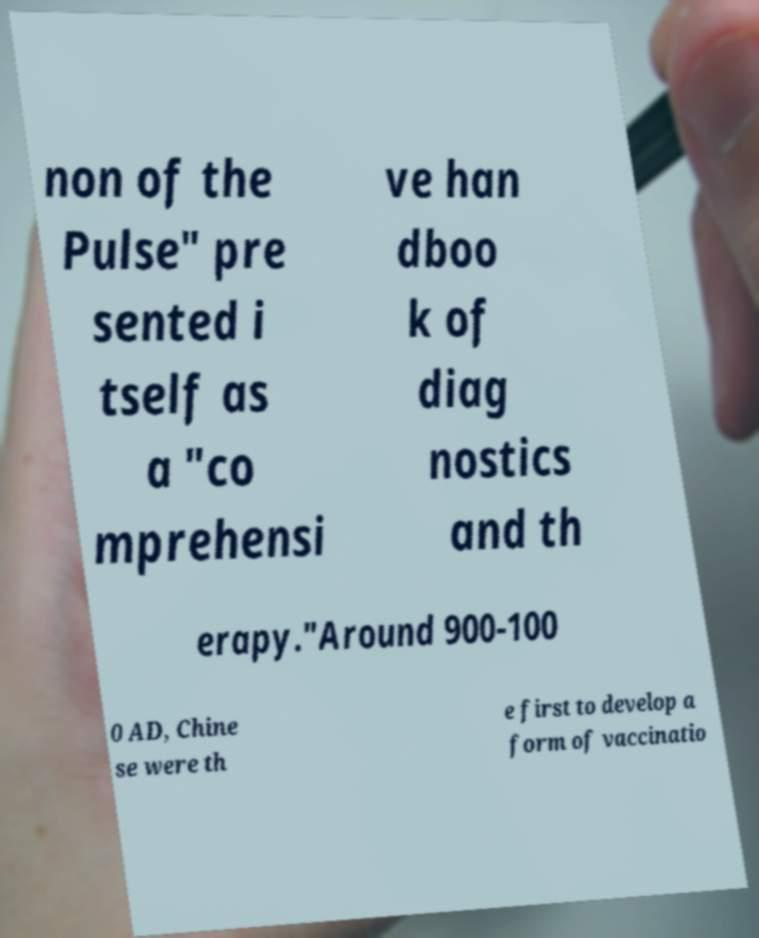Can you read and provide the text displayed in the image?This photo seems to have some interesting text. Can you extract and type it out for me? non of the Pulse" pre sented i tself as a "co mprehensi ve han dboo k of diag nostics and th erapy."Around 900-100 0 AD, Chine se were th e first to develop a form of vaccinatio 